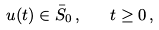<formula> <loc_0><loc_0><loc_500><loc_500>u ( t ) \in \bar { S } _ { 0 } \, , \quad t \geq 0 \, ,</formula> 